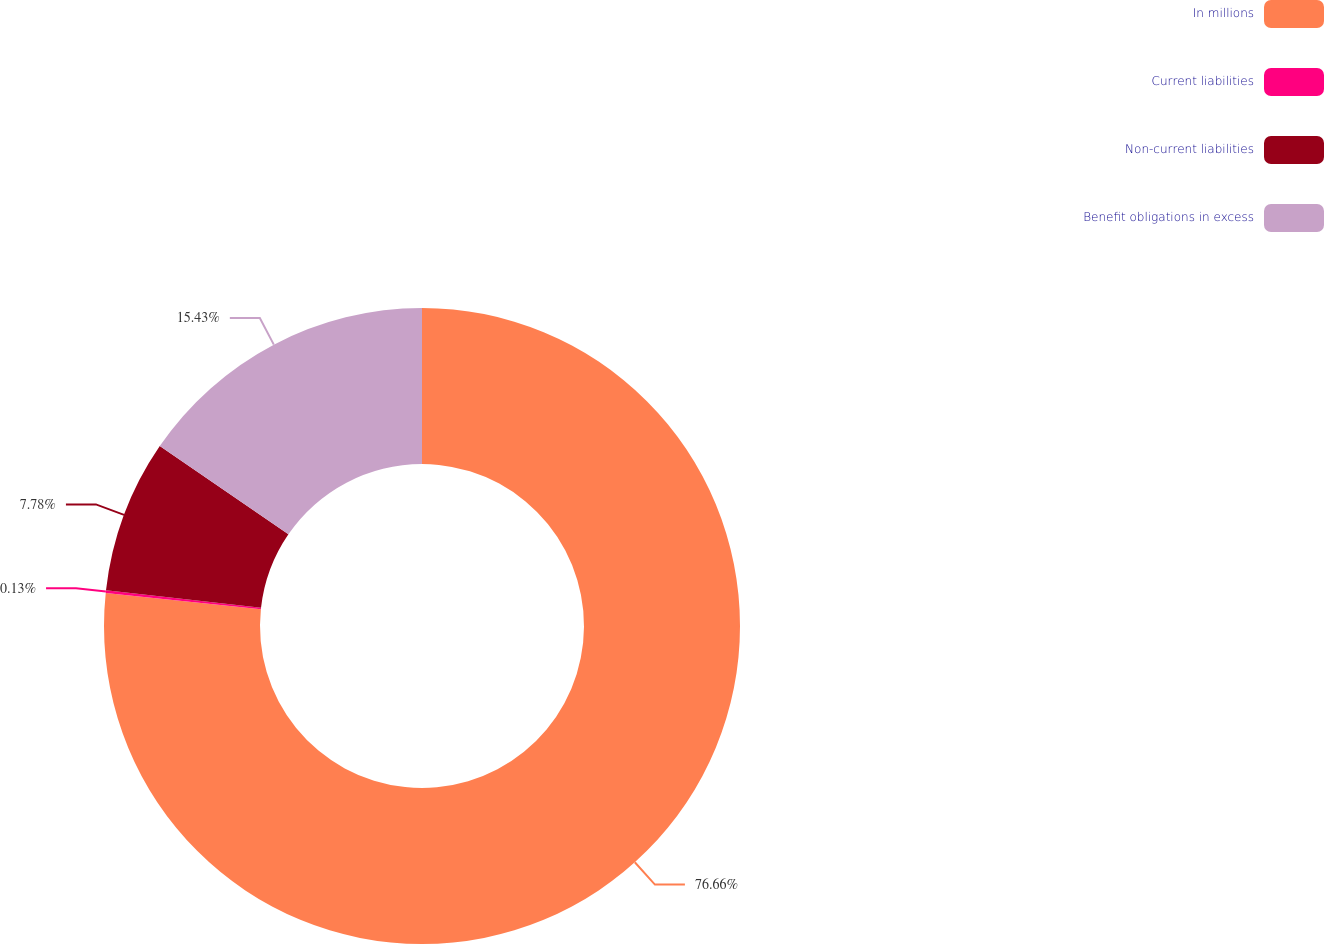Convert chart. <chart><loc_0><loc_0><loc_500><loc_500><pie_chart><fcel>In millions<fcel>Current liabilities<fcel>Non-current liabilities<fcel>Benefit obligations in excess<nl><fcel>76.66%<fcel>0.13%<fcel>7.78%<fcel>15.43%<nl></chart> 